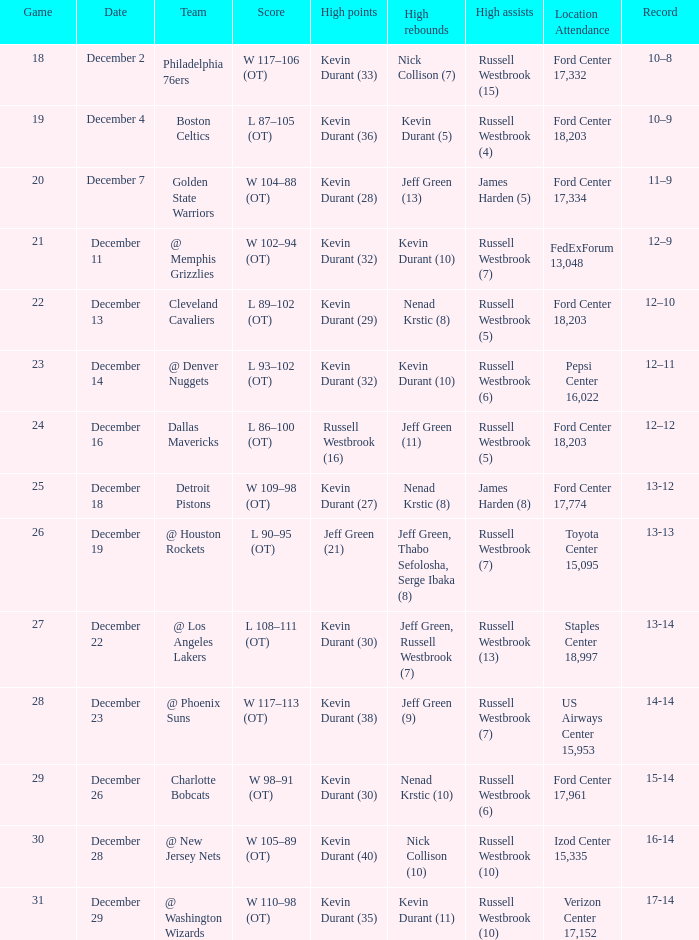What location attendance has russell westbrook (5) as high assists and nenad krstic (8) as high rebounds? Ford Center 18,203. 